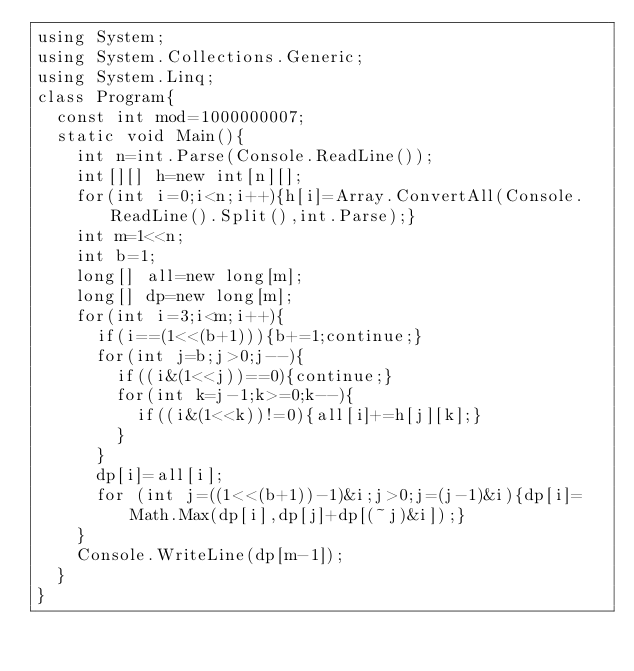Convert code to text. <code><loc_0><loc_0><loc_500><loc_500><_C#_>using System;
using System.Collections.Generic;
using System.Linq;
class Program{
	const int mod=1000000007;
	static void Main(){
		int n=int.Parse(Console.ReadLine());
		int[][] h=new int[n][];
		for(int i=0;i<n;i++){h[i]=Array.ConvertAll(Console.ReadLine().Split(),int.Parse);}
		int m=1<<n;
		int b=1;
		long[] all=new long[m];
		long[] dp=new long[m];
		for(int i=3;i<m;i++){
			if(i==(1<<(b+1))){b+=1;continue;}
			for(int j=b;j>0;j--){
				if((i&(1<<j))==0){continue;}
				for(int k=j-1;k>=0;k--){
					if((i&(1<<k))!=0){all[i]+=h[j][k];}
				}
			}
			dp[i]=all[i];
			for (int j=((1<<(b+1))-1)&i;j>0;j=(j-1)&i){dp[i]=Math.Max(dp[i],dp[j]+dp[(~j)&i]);}
		}
		Console.WriteLine(dp[m-1]);
	}
}</code> 